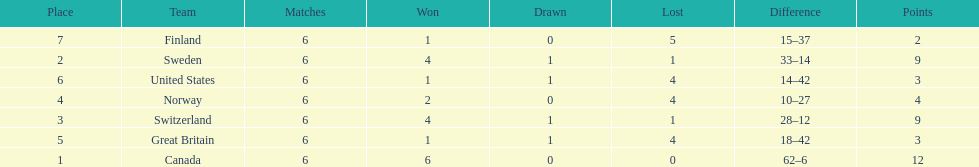Could you parse the entire table as a dict? {'header': ['Place', 'Team', 'Matches', 'Won', 'Drawn', 'Lost', 'Difference', 'Points'], 'rows': [['7', 'Finland', '6', '1', '0', '5', '15–37', '2'], ['2', 'Sweden', '6', '4', '1', '1', '33–14', '9'], ['6', 'United States', '6', '1', '1', '4', '14–42', '3'], ['4', 'Norway', '6', '2', '0', '4', '10–27', '4'], ['3', 'Switzerland', '6', '4', '1', '1', '28–12', '9'], ['5', 'Great Britain', '6', '1', '1', '4', '18–42', '3'], ['1', 'Canada', '6', '6', '0', '0', '62–6', '12']]} During the 1951 world ice hockey championships, what was the difference between the first and last place teams for number of games won ? 5. 